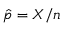<formula> <loc_0><loc_0><loc_500><loc_500>{ \hat { p } } = X / n</formula> 